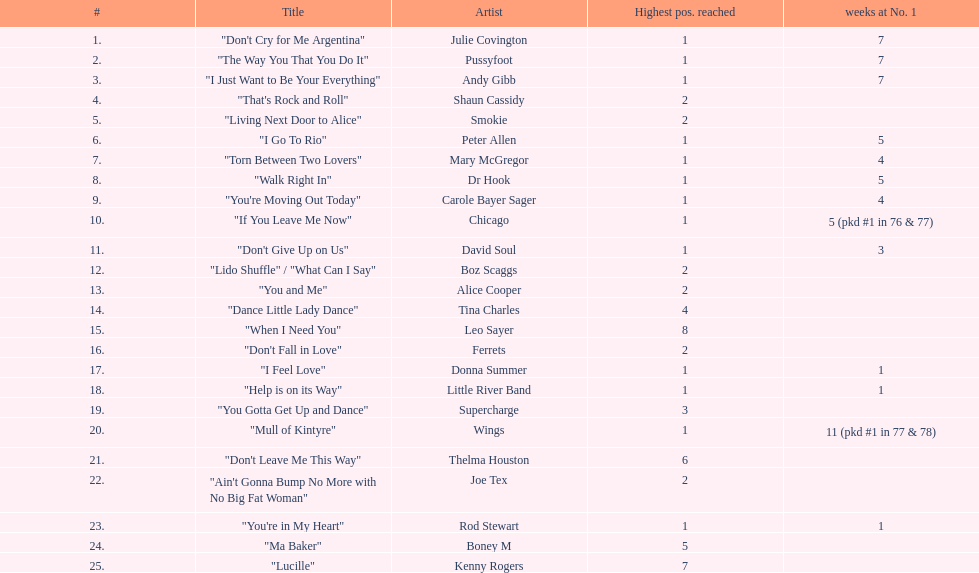Which performers made it to the top 25 singles for 1977 in australia? Julie Covington, Pussyfoot, Andy Gibb, Shaun Cassidy, Smokie, Peter Allen, Mary McGregor, Dr Hook, Carole Bayer Sager, Chicago, David Soul, Boz Scaggs, Alice Cooper, Tina Charles, Leo Sayer, Ferrets, Donna Summer, Little River Band, Supercharge, Wings, Thelma Houston, Joe Tex, Rod Stewart, Boney M, Kenny Rogers. And for how many weeks were they at the number 1 rank? 7, 7, 7, , , 5, 4, 5, 4, 5 (pkd #1 in 76 & 77), 3, , , , , , 1, 1, , 11 (pkd #1 in 77 & 78), , , 1, , . Which artist occupied the number 1 place for the most time? Wings. 